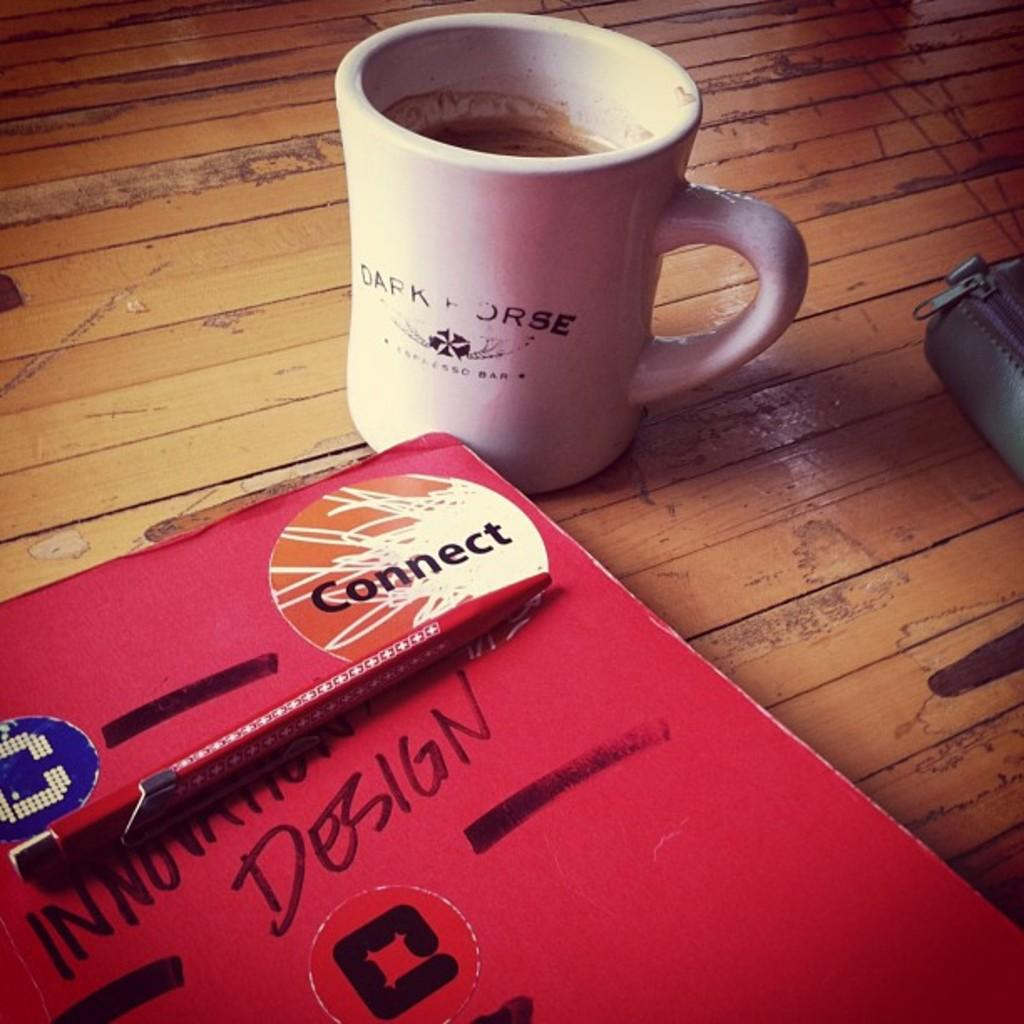<image>
Create a compact narrative representing the image presented. A Connect sticker is in the corner of a book labeled Innovation Design. 